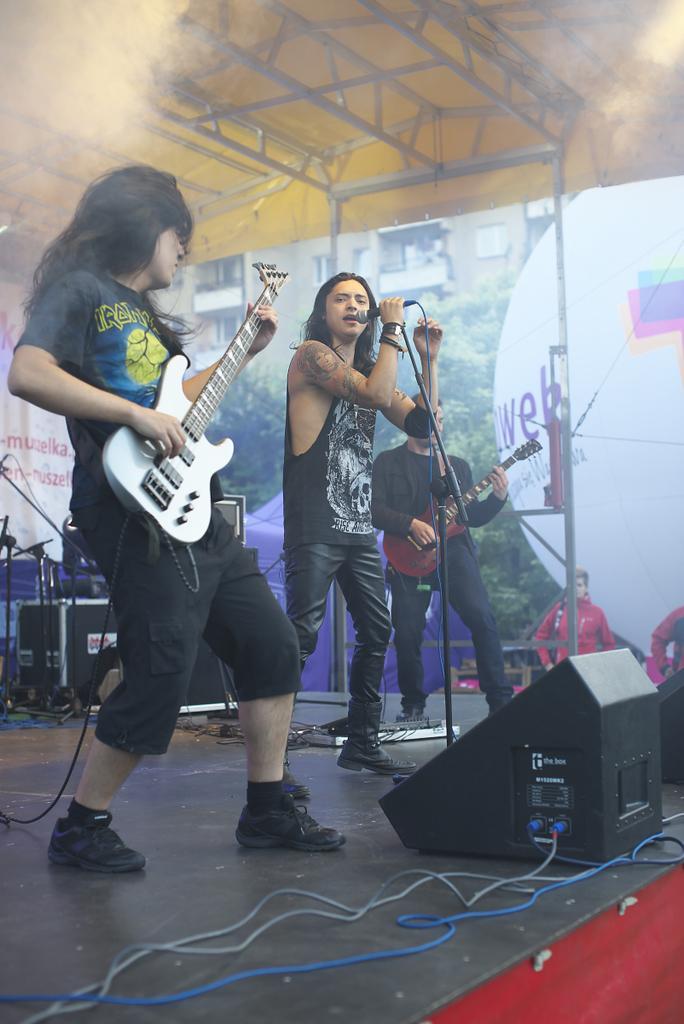Describe this image in one or two sentences. This is the picture taken on a stage, there are group of people playing the music instrument and singing a song in front of these people there is a microphone with stand. Behind the people there is a building. 